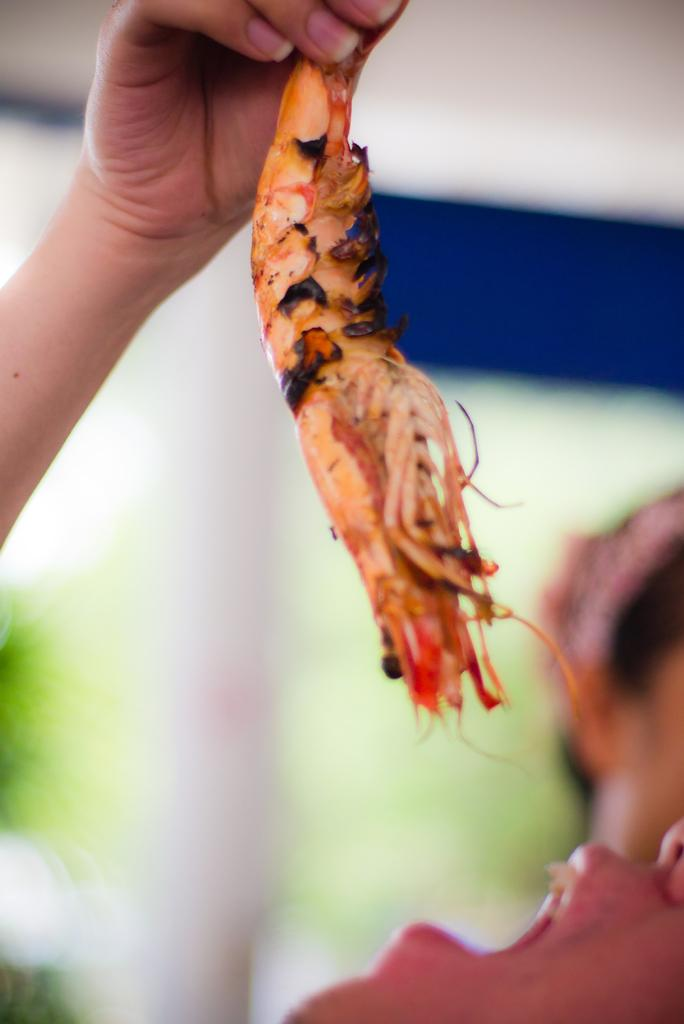What is the main subject of the image? There is a person in the image. What is the person holding in the image? The person is holding a prawn. Can you describe the background of the image? The background of the image is blurry. How many girls are present in the image? There is no mention of girls in the image, so it cannot be determined how many are present. 